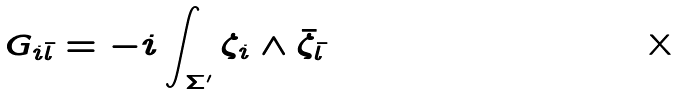Convert formula to latex. <formula><loc_0><loc_0><loc_500><loc_500>G _ { i \bar { l } } = - i \int _ { \Sigma ^ { \prime } } \zeta _ { i } \wedge \bar { \zeta } _ { \bar { l } }</formula> 